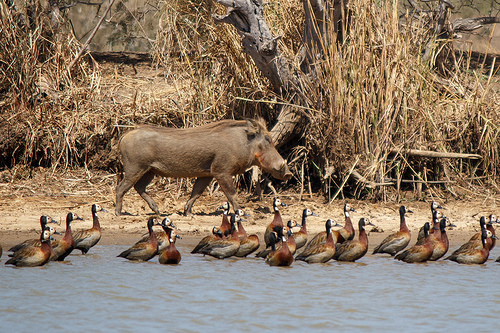<image>
Can you confirm if the bird is behind the warthog? No. The bird is not behind the warthog. From this viewpoint, the bird appears to be positioned elsewhere in the scene. 